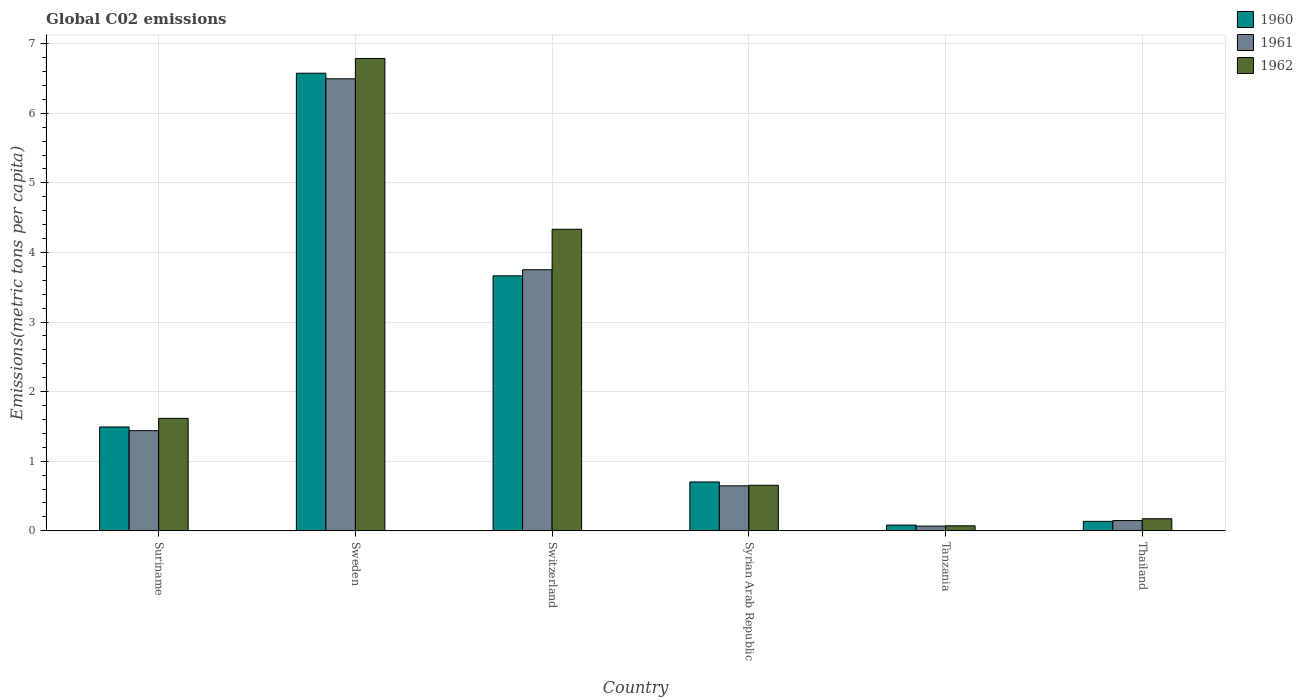How many different coloured bars are there?
Make the answer very short. 3. Are the number of bars on each tick of the X-axis equal?
Your answer should be very brief. Yes. How many bars are there on the 2nd tick from the right?
Your response must be concise. 3. What is the label of the 3rd group of bars from the left?
Your answer should be very brief. Switzerland. In how many cases, is the number of bars for a given country not equal to the number of legend labels?
Ensure brevity in your answer.  0. What is the amount of CO2 emitted in in 1962 in Suriname?
Provide a succinct answer. 1.62. Across all countries, what is the maximum amount of CO2 emitted in in 1962?
Offer a terse response. 6.79. Across all countries, what is the minimum amount of CO2 emitted in in 1962?
Give a very brief answer. 0.07. In which country was the amount of CO2 emitted in in 1960 maximum?
Your answer should be very brief. Sweden. In which country was the amount of CO2 emitted in in 1961 minimum?
Ensure brevity in your answer.  Tanzania. What is the total amount of CO2 emitted in in 1961 in the graph?
Offer a terse response. 12.55. What is the difference between the amount of CO2 emitted in in 1961 in Suriname and that in Syrian Arab Republic?
Ensure brevity in your answer.  0.79. What is the difference between the amount of CO2 emitted in in 1960 in Syrian Arab Republic and the amount of CO2 emitted in in 1962 in Suriname?
Your answer should be very brief. -0.91. What is the average amount of CO2 emitted in in 1961 per country?
Your answer should be very brief. 2.09. What is the difference between the amount of CO2 emitted in of/in 1961 and amount of CO2 emitted in of/in 1960 in Suriname?
Give a very brief answer. -0.05. In how many countries, is the amount of CO2 emitted in in 1962 greater than 2.4 metric tons per capita?
Give a very brief answer. 2. What is the ratio of the amount of CO2 emitted in in 1962 in Sweden to that in Syrian Arab Republic?
Your answer should be compact. 10.37. What is the difference between the highest and the second highest amount of CO2 emitted in in 1961?
Your answer should be compact. -2.31. What is the difference between the highest and the lowest amount of CO2 emitted in in 1962?
Offer a very short reply. 6.72. In how many countries, is the amount of CO2 emitted in in 1960 greater than the average amount of CO2 emitted in in 1960 taken over all countries?
Give a very brief answer. 2. Is the sum of the amount of CO2 emitted in in 1960 in Sweden and Thailand greater than the maximum amount of CO2 emitted in in 1962 across all countries?
Provide a succinct answer. No. What does the 3rd bar from the left in Tanzania represents?
Your answer should be very brief. 1962. How many countries are there in the graph?
Your answer should be very brief. 6. Does the graph contain grids?
Make the answer very short. Yes. Where does the legend appear in the graph?
Provide a succinct answer. Top right. How are the legend labels stacked?
Provide a short and direct response. Vertical. What is the title of the graph?
Offer a terse response. Global C02 emissions. What is the label or title of the Y-axis?
Give a very brief answer. Emissions(metric tons per capita). What is the Emissions(metric tons per capita) of 1960 in Suriname?
Keep it short and to the point. 1.49. What is the Emissions(metric tons per capita) in 1961 in Suriname?
Give a very brief answer. 1.44. What is the Emissions(metric tons per capita) of 1962 in Suriname?
Provide a succinct answer. 1.62. What is the Emissions(metric tons per capita) in 1960 in Sweden?
Give a very brief answer. 6.58. What is the Emissions(metric tons per capita) of 1961 in Sweden?
Give a very brief answer. 6.5. What is the Emissions(metric tons per capita) in 1962 in Sweden?
Your answer should be very brief. 6.79. What is the Emissions(metric tons per capita) in 1960 in Switzerland?
Make the answer very short. 3.66. What is the Emissions(metric tons per capita) of 1961 in Switzerland?
Your answer should be compact. 3.75. What is the Emissions(metric tons per capita) of 1962 in Switzerland?
Ensure brevity in your answer.  4.33. What is the Emissions(metric tons per capita) in 1960 in Syrian Arab Republic?
Make the answer very short. 0.7. What is the Emissions(metric tons per capita) of 1961 in Syrian Arab Republic?
Ensure brevity in your answer.  0.65. What is the Emissions(metric tons per capita) of 1962 in Syrian Arab Republic?
Your response must be concise. 0.65. What is the Emissions(metric tons per capita) in 1960 in Tanzania?
Provide a short and direct response. 0.08. What is the Emissions(metric tons per capita) in 1961 in Tanzania?
Your response must be concise. 0.07. What is the Emissions(metric tons per capita) in 1962 in Tanzania?
Your answer should be compact. 0.07. What is the Emissions(metric tons per capita) of 1960 in Thailand?
Offer a very short reply. 0.14. What is the Emissions(metric tons per capita) of 1961 in Thailand?
Keep it short and to the point. 0.15. What is the Emissions(metric tons per capita) in 1962 in Thailand?
Your answer should be compact. 0.17. Across all countries, what is the maximum Emissions(metric tons per capita) of 1960?
Your answer should be compact. 6.58. Across all countries, what is the maximum Emissions(metric tons per capita) in 1961?
Your answer should be compact. 6.5. Across all countries, what is the maximum Emissions(metric tons per capita) of 1962?
Provide a succinct answer. 6.79. Across all countries, what is the minimum Emissions(metric tons per capita) of 1960?
Your answer should be compact. 0.08. Across all countries, what is the minimum Emissions(metric tons per capita) in 1961?
Your response must be concise. 0.07. Across all countries, what is the minimum Emissions(metric tons per capita) of 1962?
Keep it short and to the point. 0.07. What is the total Emissions(metric tons per capita) in 1960 in the graph?
Your response must be concise. 12.65. What is the total Emissions(metric tons per capita) in 1961 in the graph?
Keep it short and to the point. 12.55. What is the total Emissions(metric tons per capita) of 1962 in the graph?
Offer a very short reply. 13.64. What is the difference between the Emissions(metric tons per capita) of 1960 in Suriname and that in Sweden?
Give a very brief answer. -5.08. What is the difference between the Emissions(metric tons per capita) of 1961 in Suriname and that in Sweden?
Provide a short and direct response. -5.06. What is the difference between the Emissions(metric tons per capita) of 1962 in Suriname and that in Sweden?
Your answer should be very brief. -5.17. What is the difference between the Emissions(metric tons per capita) of 1960 in Suriname and that in Switzerland?
Provide a succinct answer. -2.17. What is the difference between the Emissions(metric tons per capita) of 1961 in Suriname and that in Switzerland?
Provide a succinct answer. -2.31. What is the difference between the Emissions(metric tons per capita) in 1962 in Suriname and that in Switzerland?
Ensure brevity in your answer.  -2.72. What is the difference between the Emissions(metric tons per capita) of 1960 in Suriname and that in Syrian Arab Republic?
Offer a very short reply. 0.79. What is the difference between the Emissions(metric tons per capita) of 1961 in Suriname and that in Syrian Arab Republic?
Make the answer very short. 0.79. What is the difference between the Emissions(metric tons per capita) in 1962 in Suriname and that in Syrian Arab Republic?
Offer a very short reply. 0.96. What is the difference between the Emissions(metric tons per capita) in 1960 in Suriname and that in Tanzania?
Offer a very short reply. 1.41. What is the difference between the Emissions(metric tons per capita) of 1961 in Suriname and that in Tanzania?
Your response must be concise. 1.37. What is the difference between the Emissions(metric tons per capita) of 1962 in Suriname and that in Tanzania?
Your response must be concise. 1.54. What is the difference between the Emissions(metric tons per capita) of 1960 in Suriname and that in Thailand?
Your answer should be compact. 1.36. What is the difference between the Emissions(metric tons per capita) in 1961 in Suriname and that in Thailand?
Your answer should be compact. 1.29. What is the difference between the Emissions(metric tons per capita) in 1962 in Suriname and that in Thailand?
Your answer should be compact. 1.44. What is the difference between the Emissions(metric tons per capita) of 1960 in Sweden and that in Switzerland?
Make the answer very short. 2.91. What is the difference between the Emissions(metric tons per capita) of 1961 in Sweden and that in Switzerland?
Provide a short and direct response. 2.74. What is the difference between the Emissions(metric tons per capita) of 1962 in Sweden and that in Switzerland?
Offer a terse response. 2.45. What is the difference between the Emissions(metric tons per capita) of 1960 in Sweden and that in Syrian Arab Republic?
Your answer should be compact. 5.87. What is the difference between the Emissions(metric tons per capita) in 1961 in Sweden and that in Syrian Arab Republic?
Offer a terse response. 5.85. What is the difference between the Emissions(metric tons per capita) of 1962 in Sweden and that in Syrian Arab Republic?
Make the answer very short. 6.13. What is the difference between the Emissions(metric tons per capita) in 1960 in Sweden and that in Tanzania?
Offer a very short reply. 6.49. What is the difference between the Emissions(metric tons per capita) of 1961 in Sweden and that in Tanzania?
Make the answer very short. 6.43. What is the difference between the Emissions(metric tons per capita) in 1962 in Sweden and that in Tanzania?
Ensure brevity in your answer.  6.72. What is the difference between the Emissions(metric tons per capita) of 1960 in Sweden and that in Thailand?
Ensure brevity in your answer.  6.44. What is the difference between the Emissions(metric tons per capita) in 1961 in Sweden and that in Thailand?
Make the answer very short. 6.35. What is the difference between the Emissions(metric tons per capita) of 1962 in Sweden and that in Thailand?
Your answer should be very brief. 6.61. What is the difference between the Emissions(metric tons per capita) of 1960 in Switzerland and that in Syrian Arab Republic?
Offer a very short reply. 2.96. What is the difference between the Emissions(metric tons per capita) in 1961 in Switzerland and that in Syrian Arab Republic?
Your answer should be compact. 3.11. What is the difference between the Emissions(metric tons per capita) in 1962 in Switzerland and that in Syrian Arab Republic?
Make the answer very short. 3.68. What is the difference between the Emissions(metric tons per capita) of 1960 in Switzerland and that in Tanzania?
Give a very brief answer. 3.58. What is the difference between the Emissions(metric tons per capita) in 1961 in Switzerland and that in Tanzania?
Your answer should be very brief. 3.68. What is the difference between the Emissions(metric tons per capita) of 1962 in Switzerland and that in Tanzania?
Offer a very short reply. 4.26. What is the difference between the Emissions(metric tons per capita) of 1960 in Switzerland and that in Thailand?
Offer a very short reply. 3.53. What is the difference between the Emissions(metric tons per capita) in 1961 in Switzerland and that in Thailand?
Your answer should be compact. 3.6. What is the difference between the Emissions(metric tons per capita) of 1962 in Switzerland and that in Thailand?
Provide a short and direct response. 4.16. What is the difference between the Emissions(metric tons per capita) of 1960 in Syrian Arab Republic and that in Tanzania?
Provide a succinct answer. 0.62. What is the difference between the Emissions(metric tons per capita) of 1961 in Syrian Arab Republic and that in Tanzania?
Keep it short and to the point. 0.58. What is the difference between the Emissions(metric tons per capita) of 1962 in Syrian Arab Republic and that in Tanzania?
Give a very brief answer. 0.58. What is the difference between the Emissions(metric tons per capita) of 1960 in Syrian Arab Republic and that in Thailand?
Offer a terse response. 0.57. What is the difference between the Emissions(metric tons per capita) of 1961 in Syrian Arab Republic and that in Thailand?
Your response must be concise. 0.5. What is the difference between the Emissions(metric tons per capita) in 1962 in Syrian Arab Republic and that in Thailand?
Provide a succinct answer. 0.48. What is the difference between the Emissions(metric tons per capita) of 1960 in Tanzania and that in Thailand?
Offer a very short reply. -0.05. What is the difference between the Emissions(metric tons per capita) of 1961 in Tanzania and that in Thailand?
Provide a succinct answer. -0.08. What is the difference between the Emissions(metric tons per capita) in 1962 in Tanzania and that in Thailand?
Give a very brief answer. -0.1. What is the difference between the Emissions(metric tons per capita) of 1960 in Suriname and the Emissions(metric tons per capita) of 1961 in Sweden?
Offer a very short reply. -5. What is the difference between the Emissions(metric tons per capita) of 1960 in Suriname and the Emissions(metric tons per capita) of 1962 in Sweden?
Provide a succinct answer. -5.3. What is the difference between the Emissions(metric tons per capita) in 1961 in Suriname and the Emissions(metric tons per capita) in 1962 in Sweden?
Make the answer very short. -5.35. What is the difference between the Emissions(metric tons per capita) in 1960 in Suriname and the Emissions(metric tons per capita) in 1961 in Switzerland?
Give a very brief answer. -2.26. What is the difference between the Emissions(metric tons per capita) in 1960 in Suriname and the Emissions(metric tons per capita) in 1962 in Switzerland?
Offer a terse response. -2.84. What is the difference between the Emissions(metric tons per capita) in 1961 in Suriname and the Emissions(metric tons per capita) in 1962 in Switzerland?
Provide a short and direct response. -2.89. What is the difference between the Emissions(metric tons per capita) in 1960 in Suriname and the Emissions(metric tons per capita) in 1961 in Syrian Arab Republic?
Provide a short and direct response. 0.85. What is the difference between the Emissions(metric tons per capita) in 1960 in Suriname and the Emissions(metric tons per capita) in 1962 in Syrian Arab Republic?
Give a very brief answer. 0.84. What is the difference between the Emissions(metric tons per capita) of 1961 in Suriname and the Emissions(metric tons per capita) of 1962 in Syrian Arab Republic?
Provide a short and direct response. 0.78. What is the difference between the Emissions(metric tons per capita) in 1960 in Suriname and the Emissions(metric tons per capita) in 1961 in Tanzania?
Ensure brevity in your answer.  1.42. What is the difference between the Emissions(metric tons per capita) in 1960 in Suriname and the Emissions(metric tons per capita) in 1962 in Tanzania?
Make the answer very short. 1.42. What is the difference between the Emissions(metric tons per capita) of 1961 in Suriname and the Emissions(metric tons per capita) of 1962 in Tanzania?
Offer a very short reply. 1.37. What is the difference between the Emissions(metric tons per capita) of 1960 in Suriname and the Emissions(metric tons per capita) of 1961 in Thailand?
Offer a very short reply. 1.35. What is the difference between the Emissions(metric tons per capita) in 1960 in Suriname and the Emissions(metric tons per capita) in 1962 in Thailand?
Give a very brief answer. 1.32. What is the difference between the Emissions(metric tons per capita) in 1961 in Suriname and the Emissions(metric tons per capita) in 1962 in Thailand?
Ensure brevity in your answer.  1.27. What is the difference between the Emissions(metric tons per capita) in 1960 in Sweden and the Emissions(metric tons per capita) in 1961 in Switzerland?
Offer a terse response. 2.82. What is the difference between the Emissions(metric tons per capita) of 1960 in Sweden and the Emissions(metric tons per capita) of 1962 in Switzerland?
Make the answer very short. 2.24. What is the difference between the Emissions(metric tons per capita) in 1961 in Sweden and the Emissions(metric tons per capita) in 1962 in Switzerland?
Make the answer very short. 2.16. What is the difference between the Emissions(metric tons per capita) in 1960 in Sweden and the Emissions(metric tons per capita) in 1961 in Syrian Arab Republic?
Provide a short and direct response. 5.93. What is the difference between the Emissions(metric tons per capita) in 1960 in Sweden and the Emissions(metric tons per capita) in 1962 in Syrian Arab Republic?
Offer a terse response. 5.92. What is the difference between the Emissions(metric tons per capita) in 1961 in Sweden and the Emissions(metric tons per capita) in 1962 in Syrian Arab Republic?
Keep it short and to the point. 5.84. What is the difference between the Emissions(metric tons per capita) in 1960 in Sweden and the Emissions(metric tons per capita) in 1961 in Tanzania?
Your answer should be compact. 6.51. What is the difference between the Emissions(metric tons per capita) in 1960 in Sweden and the Emissions(metric tons per capita) in 1962 in Tanzania?
Offer a terse response. 6.5. What is the difference between the Emissions(metric tons per capita) in 1961 in Sweden and the Emissions(metric tons per capita) in 1962 in Tanzania?
Provide a short and direct response. 6.42. What is the difference between the Emissions(metric tons per capita) in 1960 in Sweden and the Emissions(metric tons per capita) in 1961 in Thailand?
Keep it short and to the point. 6.43. What is the difference between the Emissions(metric tons per capita) of 1960 in Sweden and the Emissions(metric tons per capita) of 1962 in Thailand?
Ensure brevity in your answer.  6.4. What is the difference between the Emissions(metric tons per capita) of 1961 in Sweden and the Emissions(metric tons per capita) of 1962 in Thailand?
Provide a succinct answer. 6.32. What is the difference between the Emissions(metric tons per capita) of 1960 in Switzerland and the Emissions(metric tons per capita) of 1961 in Syrian Arab Republic?
Make the answer very short. 3.02. What is the difference between the Emissions(metric tons per capita) of 1960 in Switzerland and the Emissions(metric tons per capita) of 1962 in Syrian Arab Republic?
Ensure brevity in your answer.  3.01. What is the difference between the Emissions(metric tons per capita) of 1961 in Switzerland and the Emissions(metric tons per capita) of 1962 in Syrian Arab Republic?
Your answer should be compact. 3.1. What is the difference between the Emissions(metric tons per capita) of 1960 in Switzerland and the Emissions(metric tons per capita) of 1961 in Tanzania?
Provide a succinct answer. 3.6. What is the difference between the Emissions(metric tons per capita) in 1960 in Switzerland and the Emissions(metric tons per capita) in 1962 in Tanzania?
Make the answer very short. 3.59. What is the difference between the Emissions(metric tons per capita) of 1961 in Switzerland and the Emissions(metric tons per capita) of 1962 in Tanzania?
Make the answer very short. 3.68. What is the difference between the Emissions(metric tons per capita) in 1960 in Switzerland and the Emissions(metric tons per capita) in 1961 in Thailand?
Offer a very short reply. 3.52. What is the difference between the Emissions(metric tons per capita) of 1960 in Switzerland and the Emissions(metric tons per capita) of 1962 in Thailand?
Your response must be concise. 3.49. What is the difference between the Emissions(metric tons per capita) of 1961 in Switzerland and the Emissions(metric tons per capita) of 1962 in Thailand?
Your answer should be compact. 3.58. What is the difference between the Emissions(metric tons per capita) in 1960 in Syrian Arab Republic and the Emissions(metric tons per capita) in 1961 in Tanzania?
Make the answer very short. 0.63. What is the difference between the Emissions(metric tons per capita) of 1960 in Syrian Arab Republic and the Emissions(metric tons per capita) of 1962 in Tanzania?
Provide a succinct answer. 0.63. What is the difference between the Emissions(metric tons per capita) of 1961 in Syrian Arab Republic and the Emissions(metric tons per capita) of 1962 in Tanzania?
Give a very brief answer. 0.57. What is the difference between the Emissions(metric tons per capita) in 1960 in Syrian Arab Republic and the Emissions(metric tons per capita) in 1961 in Thailand?
Your answer should be very brief. 0.55. What is the difference between the Emissions(metric tons per capita) of 1960 in Syrian Arab Republic and the Emissions(metric tons per capita) of 1962 in Thailand?
Make the answer very short. 0.53. What is the difference between the Emissions(metric tons per capita) of 1961 in Syrian Arab Republic and the Emissions(metric tons per capita) of 1962 in Thailand?
Make the answer very short. 0.47. What is the difference between the Emissions(metric tons per capita) of 1960 in Tanzania and the Emissions(metric tons per capita) of 1961 in Thailand?
Provide a short and direct response. -0.06. What is the difference between the Emissions(metric tons per capita) of 1960 in Tanzania and the Emissions(metric tons per capita) of 1962 in Thailand?
Provide a succinct answer. -0.09. What is the difference between the Emissions(metric tons per capita) in 1961 in Tanzania and the Emissions(metric tons per capita) in 1962 in Thailand?
Provide a short and direct response. -0.11. What is the average Emissions(metric tons per capita) of 1960 per country?
Keep it short and to the point. 2.11. What is the average Emissions(metric tons per capita) in 1961 per country?
Make the answer very short. 2.09. What is the average Emissions(metric tons per capita) in 1962 per country?
Your answer should be very brief. 2.27. What is the difference between the Emissions(metric tons per capita) of 1960 and Emissions(metric tons per capita) of 1961 in Suriname?
Ensure brevity in your answer.  0.05. What is the difference between the Emissions(metric tons per capita) of 1960 and Emissions(metric tons per capita) of 1962 in Suriname?
Offer a terse response. -0.12. What is the difference between the Emissions(metric tons per capita) of 1961 and Emissions(metric tons per capita) of 1962 in Suriname?
Your answer should be very brief. -0.18. What is the difference between the Emissions(metric tons per capita) in 1960 and Emissions(metric tons per capita) in 1961 in Sweden?
Provide a short and direct response. 0.08. What is the difference between the Emissions(metric tons per capita) of 1960 and Emissions(metric tons per capita) of 1962 in Sweden?
Keep it short and to the point. -0.21. What is the difference between the Emissions(metric tons per capita) of 1961 and Emissions(metric tons per capita) of 1962 in Sweden?
Your answer should be very brief. -0.29. What is the difference between the Emissions(metric tons per capita) in 1960 and Emissions(metric tons per capita) in 1961 in Switzerland?
Ensure brevity in your answer.  -0.09. What is the difference between the Emissions(metric tons per capita) of 1960 and Emissions(metric tons per capita) of 1962 in Switzerland?
Keep it short and to the point. -0.67. What is the difference between the Emissions(metric tons per capita) of 1961 and Emissions(metric tons per capita) of 1962 in Switzerland?
Offer a terse response. -0.58. What is the difference between the Emissions(metric tons per capita) in 1960 and Emissions(metric tons per capita) in 1961 in Syrian Arab Republic?
Keep it short and to the point. 0.06. What is the difference between the Emissions(metric tons per capita) of 1960 and Emissions(metric tons per capita) of 1962 in Syrian Arab Republic?
Keep it short and to the point. 0.05. What is the difference between the Emissions(metric tons per capita) of 1961 and Emissions(metric tons per capita) of 1962 in Syrian Arab Republic?
Give a very brief answer. -0.01. What is the difference between the Emissions(metric tons per capita) in 1960 and Emissions(metric tons per capita) in 1961 in Tanzania?
Provide a succinct answer. 0.01. What is the difference between the Emissions(metric tons per capita) of 1960 and Emissions(metric tons per capita) of 1962 in Tanzania?
Keep it short and to the point. 0.01. What is the difference between the Emissions(metric tons per capita) in 1961 and Emissions(metric tons per capita) in 1962 in Tanzania?
Ensure brevity in your answer.  -0. What is the difference between the Emissions(metric tons per capita) in 1960 and Emissions(metric tons per capita) in 1961 in Thailand?
Your answer should be very brief. -0.01. What is the difference between the Emissions(metric tons per capita) of 1960 and Emissions(metric tons per capita) of 1962 in Thailand?
Give a very brief answer. -0.04. What is the difference between the Emissions(metric tons per capita) of 1961 and Emissions(metric tons per capita) of 1962 in Thailand?
Your response must be concise. -0.03. What is the ratio of the Emissions(metric tons per capita) of 1960 in Suriname to that in Sweden?
Make the answer very short. 0.23. What is the ratio of the Emissions(metric tons per capita) in 1961 in Suriname to that in Sweden?
Offer a terse response. 0.22. What is the ratio of the Emissions(metric tons per capita) of 1962 in Suriname to that in Sweden?
Your response must be concise. 0.24. What is the ratio of the Emissions(metric tons per capita) in 1960 in Suriname to that in Switzerland?
Ensure brevity in your answer.  0.41. What is the ratio of the Emissions(metric tons per capita) of 1961 in Suriname to that in Switzerland?
Provide a succinct answer. 0.38. What is the ratio of the Emissions(metric tons per capita) of 1962 in Suriname to that in Switzerland?
Your answer should be compact. 0.37. What is the ratio of the Emissions(metric tons per capita) of 1960 in Suriname to that in Syrian Arab Republic?
Offer a terse response. 2.13. What is the ratio of the Emissions(metric tons per capita) of 1961 in Suriname to that in Syrian Arab Republic?
Offer a terse response. 2.23. What is the ratio of the Emissions(metric tons per capita) in 1962 in Suriname to that in Syrian Arab Republic?
Provide a succinct answer. 2.47. What is the ratio of the Emissions(metric tons per capita) in 1960 in Suriname to that in Tanzania?
Give a very brief answer. 18.14. What is the ratio of the Emissions(metric tons per capita) in 1961 in Suriname to that in Tanzania?
Offer a very short reply. 21.2. What is the ratio of the Emissions(metric tons per capita) in 1962 in Suriname to that in Tanzania?
Give a very brief answer. 22.53. What is the ratio of the Emissions(metric tons per capita) of 1960 in Suriname to that in Thailand?
Your answer should be very brief. 11.01. What is the ratio of the Emissions(metric tons per capita) in 1961 in Suriname to that in Thailand?
Your response must be concise. 9.79. What is the ratio of the Emissions(metric tons per capita) of 1962 in Suriname to that in Thailand?
Your response must be concise. 9.33. What is the ratio of the Emissions(metric tons per capita) in 1960 in Sweden to that in Switzerland?
Your answer should be very brief. 1.79. What is the ratio of the Emissions(metric tons per capita) of 1961 in Sweden to that in Switzerland?
Provide a succinct answer. 1.73. What is the ratio of the Emissions(metric tons per capita) of 1962 in Sweden to that in Switzerland?
Your response must be concise. 1.57. What is the ratio of the Emissions(metric tons per capita) of 1960 in Sweden to that in Syrian Arab Republic?
Keep it short and to the point. 9.37. What is the ratio of the Emissions(metric tons per capita) in 1961 in Sweden to that in Syrian Arab Republic?
Offer a terse response. 10.05. What is the ratio of the Emissions(metric tons per capita) of 1962 in Sweden to that in Syrian Arab Republic?
Offer a terse response. 10.37. What is the ratio of the Emissions(metric tons per capita) of 1960 in Sweden to that in Tanzania?
Offer a terse response. 79.95. What is the ratio of the Emissions(metric tons per capita) in 1961 in Sweden to that in Tanzania?
Provide a succinct answer. 95.71. What is the ratio of the Emissions(metric tons per capita) in 1962 in Sweden to that in Tanzania?
Your answer should be compact. 94.62. What is the ratio of the Emissions(metric tons per capita) in 1960 in Sweden to that in Thailand?
Provide a succinct answer. 48.5. What is the ratio of the Emissions(metric tons per capita) of 1961 in Sweden to that in Thailand?
Make the answer very short. 44.21. What is the ratio of the Emissions(metric tons per capita) in 1962 in Sweden to that in Thailand?
Ensure brevity in your answer.  39.21. What is the ratio of the Emissions(metric tons per capita) in 1960 in Switzerland to that in Syrian Arab Republic?
Ensure brevity in your answer.  5.22. What is the ratio of the Emissions(metric tons per capita) of 1961 in Switzerland to that in Syrian Arab Republic?
Provide a succinct answer. 5.8. What is the ratio of the Emissions(metric tons per capita) of 1962 in Switzerland to that in Syrian Arab Republic?
Keep it short and to the point. 6.62. What is the ratio of the Emissions(metric tons per capita) of 1960 in Switzerland to that in Tanzania?
Your answer should be compact. 44.55. What is the ratio of the Emissions(metric tons per capita) of 1961 in Switzerland to that in Tanzania?
Give a very brief answer. 55.28. What is the ratio of the Emissions(metric tons per capita) in 1962 in Switzerland to that in Tanzania?
Provide a succinct answer. 60.41. What is the ratio of the Emissions(metric tons per capita) in 1960 in Switzerland to that in Thailand?
Keep it short and to the point. 27.03. What is the ratio of the Emissions(metric tons per capita) of 1961 in Switzerland to that in Thailand?
Give a very brief answer. 25.53. What is the ratio of the Emissions(metric tons per capita) of 1962 in Switzerland to that in Thailand?
Give a very brief answer. 25.03. What is the ratio of the Emissions(metric tons per capita) of 1960 in Syrian Arab Republic to that in Tanzania?
Provide a succinct answer. 8.53. What is the ratio of the Emissions(metric tons per capita) of 1961 in Syrian Arab Republic to that in Tanzania?
Keep it short and to the point. 9.52. What is the ratio of the Emissions(metric tons per capita) of 1962 in Syrian Arab Republic to that in Tanzania?
Give a very brief answer. 9.12. What is the ratio of the Emissions(metric tons per capita) in 1960 in Syrian Arab Republic to that in Thailand?
Give a very brief answer. 5.18. What is the ratio of the Emissions(metric tons per capita) of 1961 in Syrian Arab Republic to that in Thailand?
Give a very brief answer. 4.4. What is the ratio of the Emissions(metric tons per capita) in 1962 in Syrian Arab Republic to that in Thailand?
Your answer should be compact. 3.78. What is the ratio of the Emissions(metric tons per capita) of 1960 in Tanzania to that in Thailand?
Ensure brevity in your answer.  0.61. What is the ratio of the Emissions(metric tons per capita) of 1961 in Tanzania to that in Thailand?
Ensure brevity in your answer.  0.46. What is the ratio of the Emissions(metric tons per capita) in 1962 in Tanzania to that in Thailand?
Offer a very short reply. 0.41. What is the difference between the highest and the second highest Emissions(metric tons per capita) of 1960?
Ensure brevity in your answer.  2.91. What is the difference between the highest and the second highest Emissions(metric tons per capita) of 1961?
Make the answer very short. 2.74. What is the difference between the highest and the second highest Emissions(metric tons per capita) in 1962?
Ensure brevity in your answer.  2.45. What is the difference between the highest and the lowest Emissions(metric tons per capita) in 1960?
Offer a very short reply. 6.49. What is the difference between the highest and the lowest Emissions(metric tons per capita) in 1961?
Your answer should be very brief. 6.43. What is the difference between the highest and the lowest Emissions(metric tons per capita) in 1962?
Make the answer very short. 6.72. 